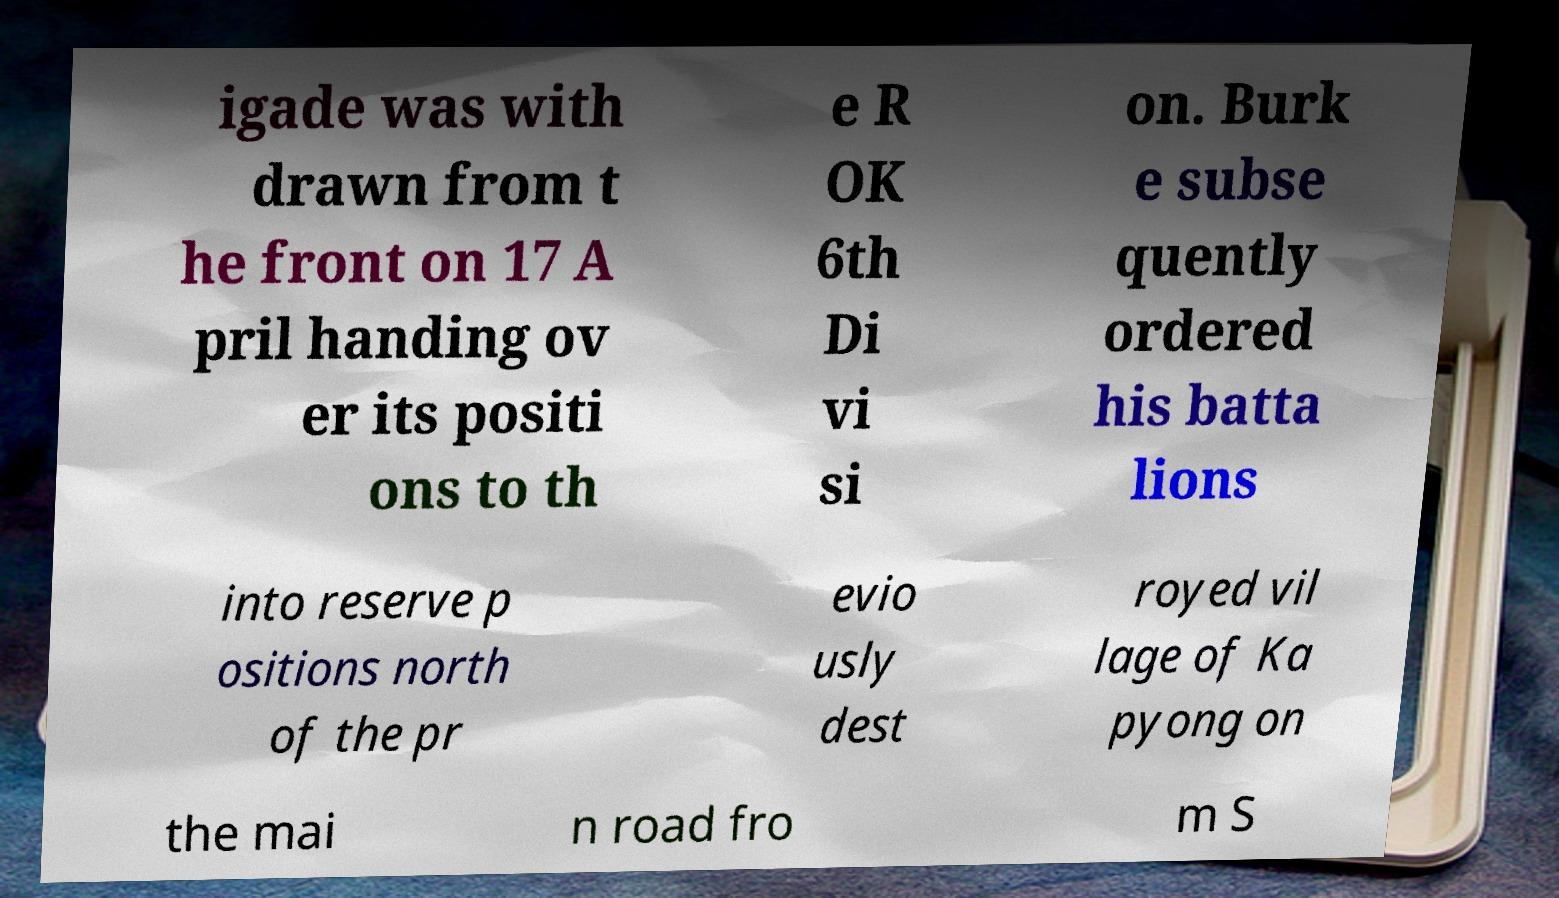Please identify and transcribe the text found in this image. igade was with drawn from t he front on 17 A pril handing ov er its positi ons to th e R OK 6th Di vi si on. Burk e subse quently ordered his batta lions into reserve p ositions north of the pr evio usly dest royed vil lage of Ka pyong on the mai n road fro m S 